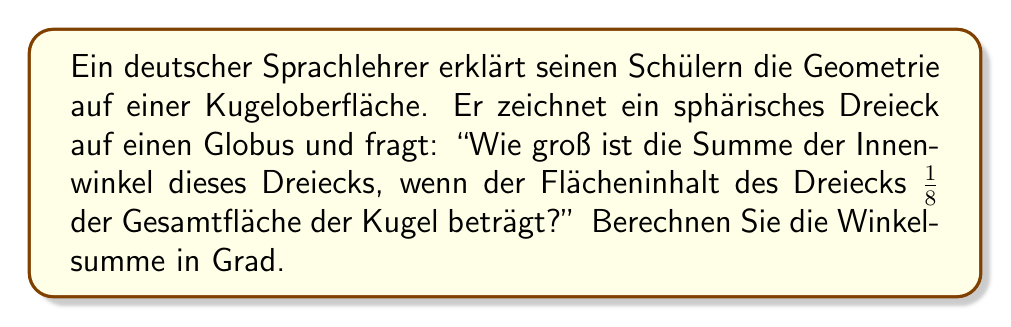Solve this math problem. 1. In der sphärischen Geometrie gilt für die Winkelsumme $S$ eines Dreiecks:
   $$S = \alpha + \beta + \gamma = 180° + \varepsilon$$
   wobei $\varepsilon$ der sphärische Exzess ist.

2. Der sphärische Exzess ist proportional zur Fläche des Dreiecks:
   $$\varepsilon = \frac{A}{R^2}$$
   wobei $A$ die Fläche des Dreiecks und $R$ der Radius der Kugel ist.

3. Gegeben ist, dass die Fläche des Dreiecks $\frac{1}{8}$ der Gesamtfläche der Kugel beträgt:
   $$A = \frac{1}{8} \cdot 4\pi R^2 = \frac{\pi R^2}{2}$$

4. Einsetzen in die Formel für den sphärischen Exzess:
   $$\varepsilon = \frac{A}{R^2} = \frac{\pi R^2/2}{R^2} = \frac{\pi}{2}$$

5. Umrechnung von Radiant in Grad:
   $$\varepsilon_{Grad} = \frac{\pi}{2} \cdot \frac{180°}{\pi} = 90°$$

6. Die Winkelsumme beträgt also:
   $$S = 180° + 90° = 270°$$
Answer: 270° 